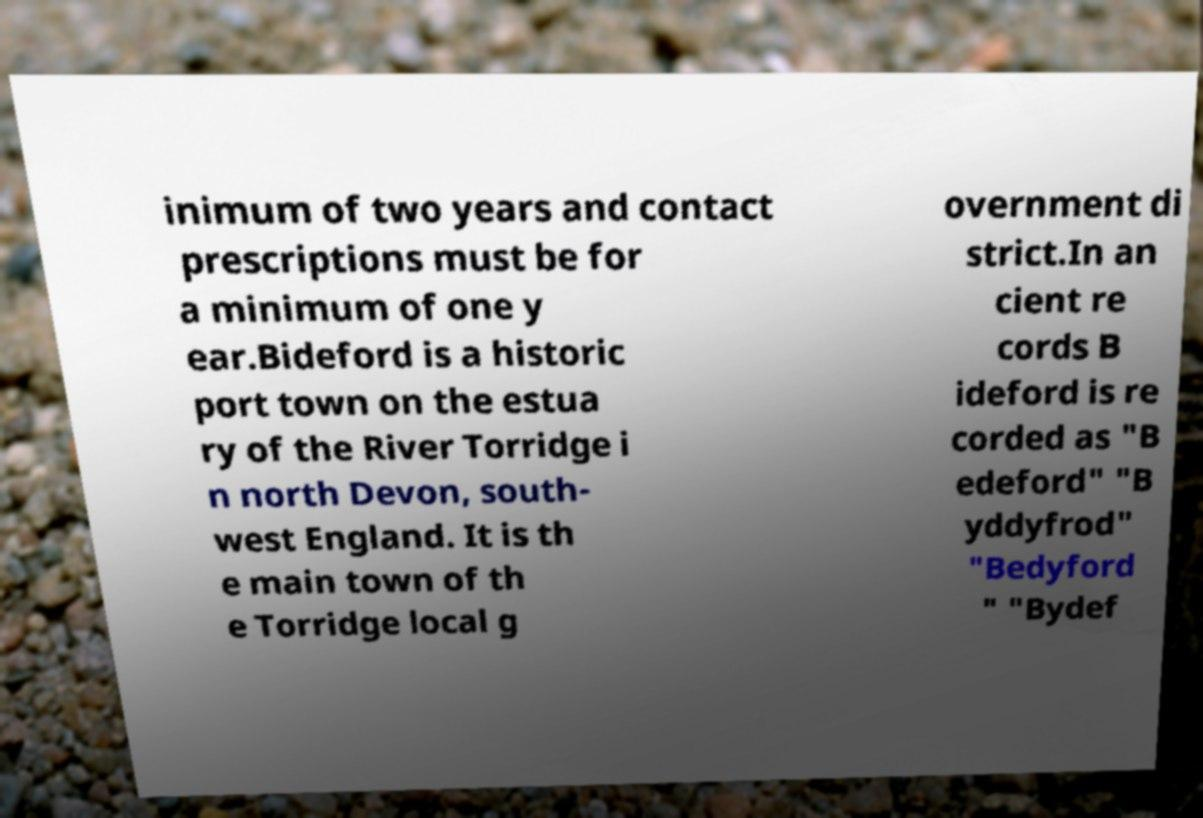There's text embedded in this image that I need extracted. Can you transcribe it verbatim? inimum of two years and contact prescriptions must be for a minimum of one y ear.Bideford is a historic port town on the estua ry of the River Torridge i n north Devon, south- west England. It is th e main town of th e Torridge local g overnment di strict.In an cient re cords B ideford is re corded as "B edeford" "B yddyfrod" "Bedyford " "Bydef 